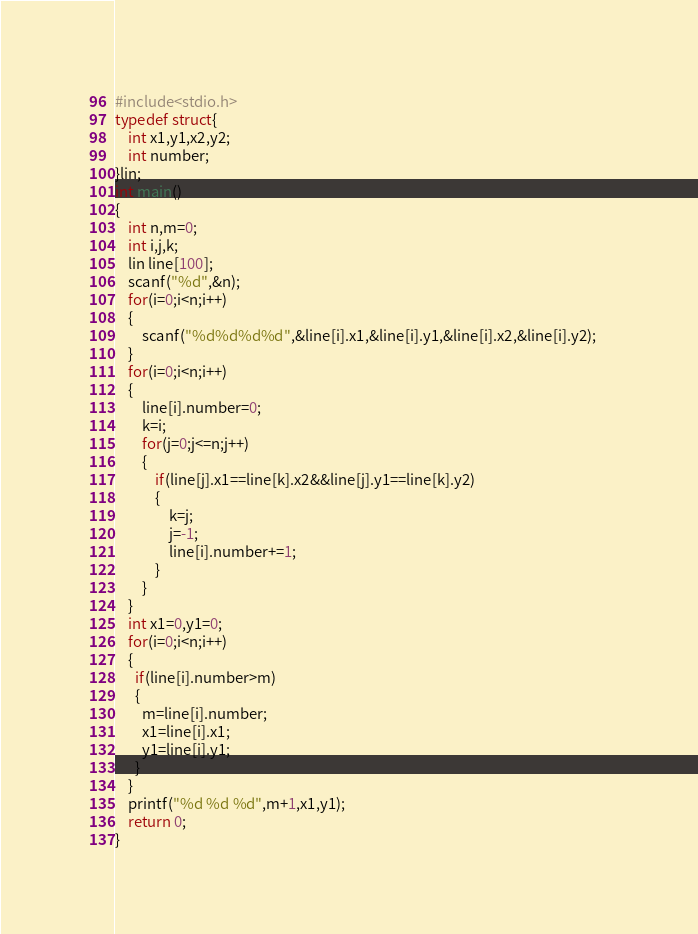<code> <loc_0><loc_0><loc_500><loc_500><_C_>#include<stdio.h>
typedef struct{
	int x1,y1,x2,y2;
	int number;
}lin;
int main()
{
	int n,m=0;
	int i,j,k;
	lin line[100];
	scanf("%d",&n);
	for(i=0;i<n;i++)
	{
		scanf("%d%d%d%d",&line[i].x1,&line[i].y1,&line[i].x2,&line[i].y2);	
	}
	for(i=0;i<n;i++)
	{
		line[i].number=0;
		k=i;
		for(j=0;j<=n;j++)
		{
			if(line[j].x1==line[k].x2&&line[j].y1==line[k].y2)
			{
				k=j;
				j=-1;
				line[i].number+=1;
			}
		}
	}
	int x1=0,y1=0;
	for(i=0;i<n;i++)
	{
	  if(line[i].number>m)
	  {
	  	m=line[i].number;
	  	x1=line[i].x1;
	  	y1=line[i].y1;
	  }
	}
	printf("%d %d %d",m+1,x1,y1);
	return 0;
}
</code> 